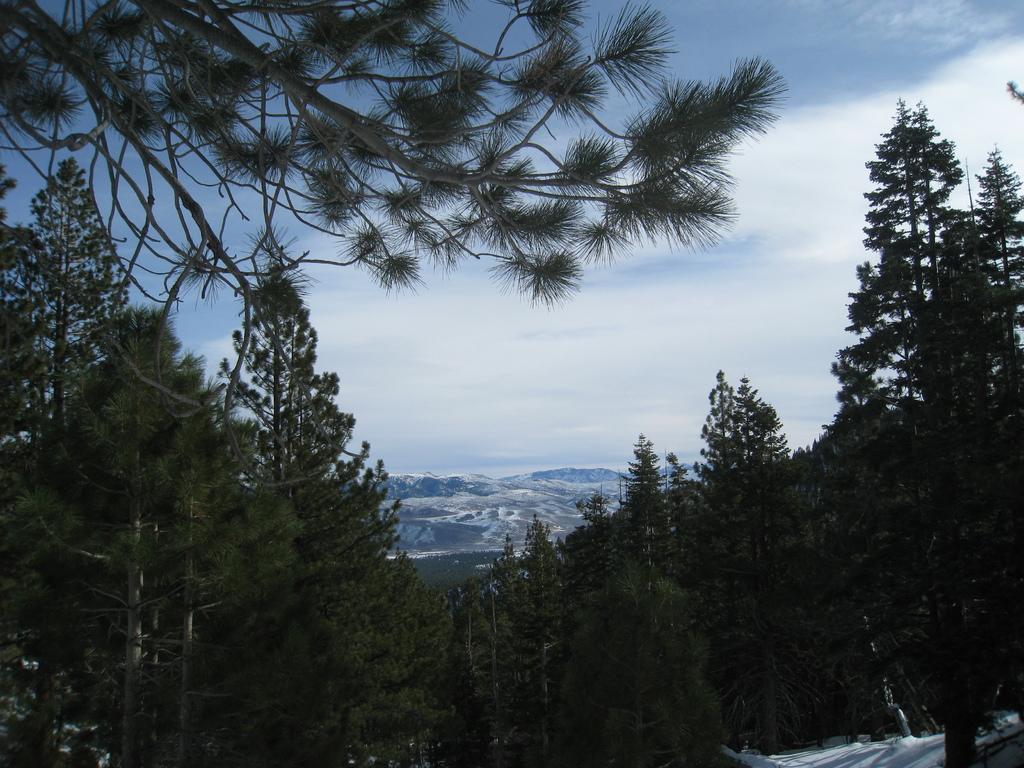Describe this image in one or two sentences. In this image I can see number of trees, clouds and the sky. 